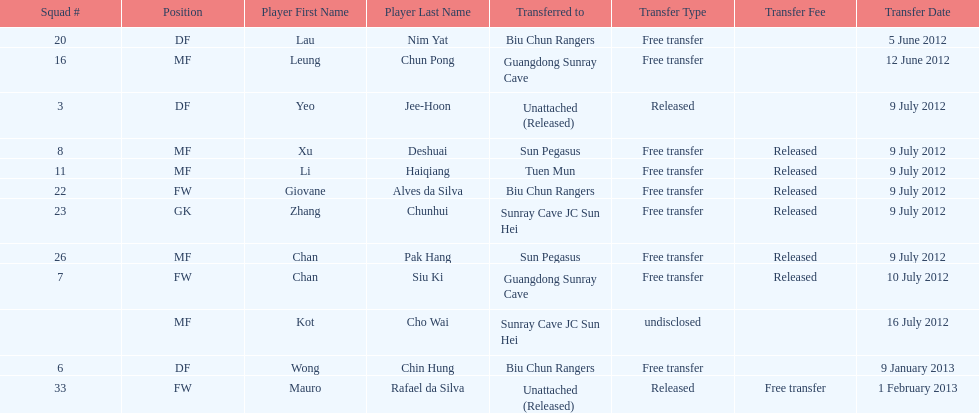Wong chin hung was transferred to his new team on what date? 9 January 2013. 